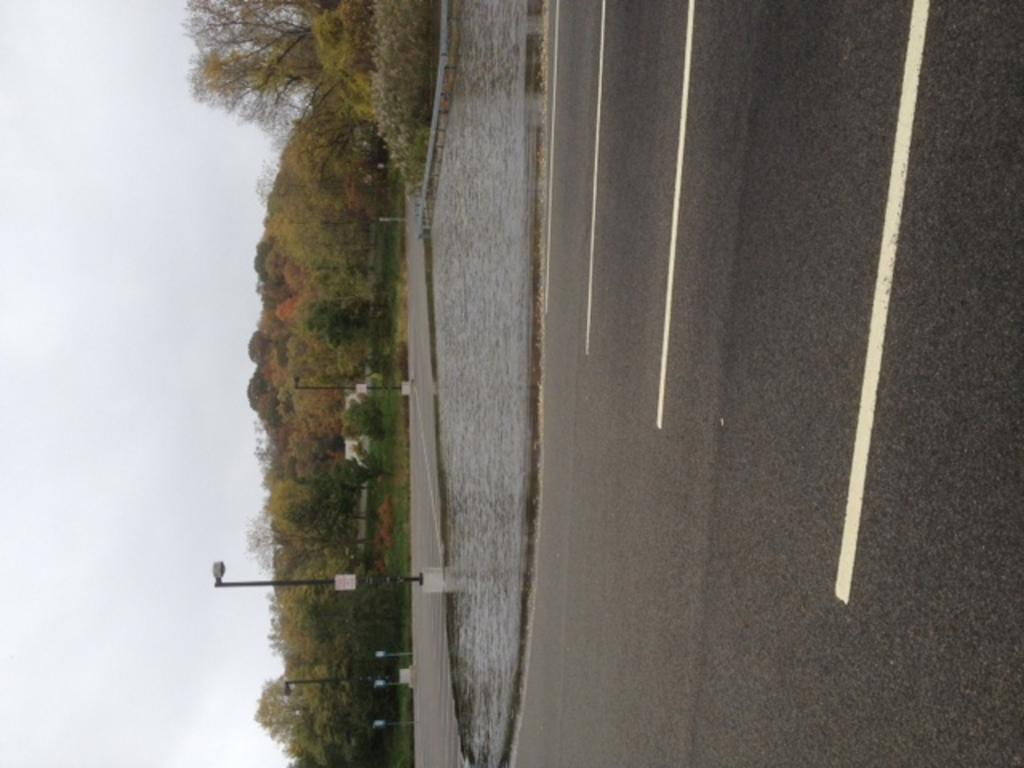What can be seen on the right side of the image? There is a road on the right side of the image. What is located near the road? There is water near the road. What structures are present in the image? There are light poles in the image. What type of vegetation is on the left side of the image? There are trees on the left side of the image. What is visible in the background of the image? The sky is visible in the image. What is the price of the brother's car in the image? There is no mention of a car or a brother in the image, so it is not possible to determine the price of a car. 